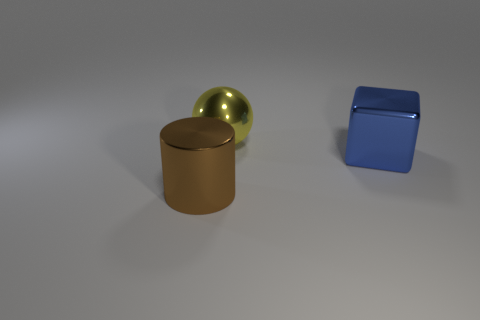Are there any big metallic cubes?
Provide a short and direct response. Yes. There is a large metal object right of the large ball; is it the same color as the big object left of the large yellow metal sphere?
Your response must be concise. No. Do the large thing on the left side of the large metal ball and the thing that is behind the big blue object have the same material?
Offer a very short reply. Yes. What number of rubber objects are either small gray cubes or large blue things?
Offer a terse response. 0. The object that is on the right side of the thing behind the metal thing to the right of the yellow thing is made of what material?
Offer a very short reply. Metal. Does the shiny thing that is to the right of the big sphere have the same shape as the object that is to the left of the yellow metal object?
Make the answer very short. No. There is a big thing that is to the left of the thing behind the big blue object; what is its color?
Make the answer very short. Brown. What number of balls are big cyan metallic things or blue metallic objects?
Offer a terse response. 0. There is a metal thing that is in front of the object that is to the right of the shiny ball; what number of big blue cubes are in front of it?
Your answer should be compact. 0. Is there a large brown cylinder made of the same material as the big yellow sphere?
Your answer should be compact. Yes. 